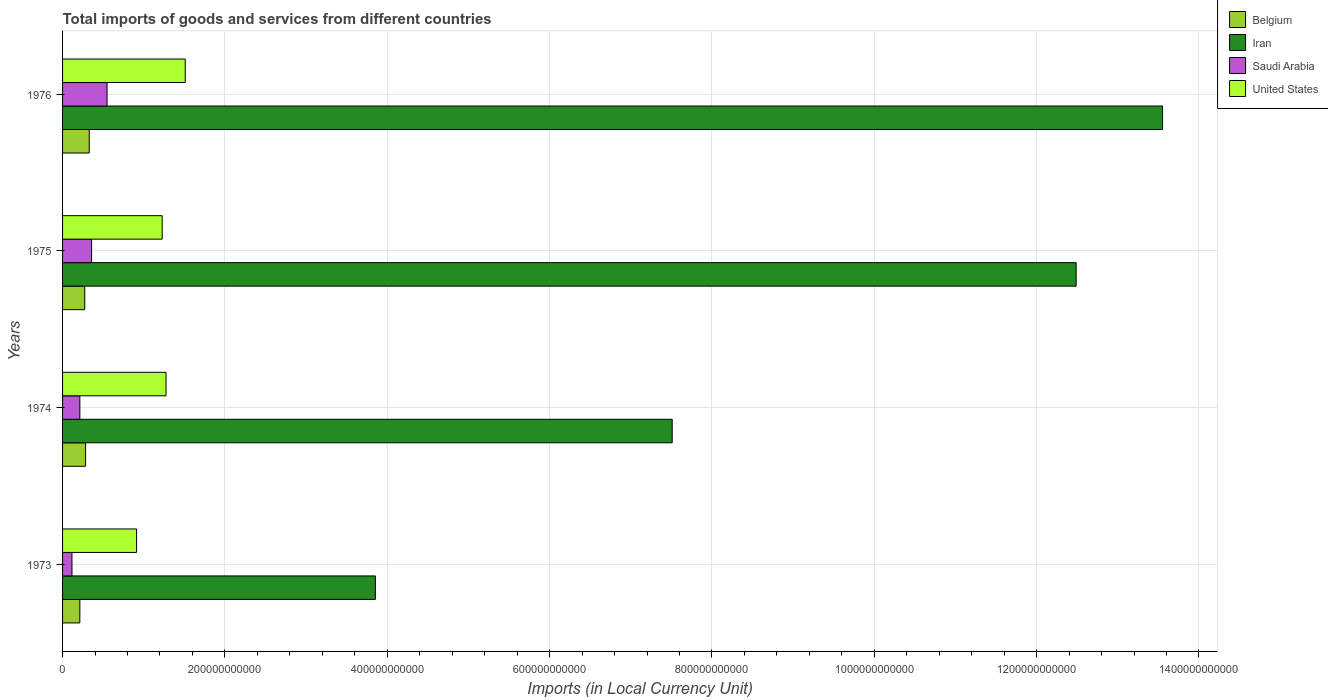How many different coloured bars are there?
Your answer should be very brief. 4. How many bars are there on the 2nd tick from the bottom?
Make the answer very short. 4. What is the label of the 3rd group of bars from the top?
Your response must be concise. 1974. In how many cases, is the number of bars for a given year not equal to the number of legend labels?
Make the answer very short. 0. What is the Amount of goods and services imports in Saudi Arabia in 1974?
Make the answer very short. 2.13e+1. Across all years, what is the maximum Amount of goods and services imports in Iran?
Your answer should be compact. 1.36e+12. Across all years, what is the minimum Amount of goods and services imports in Belgium?
Give a very brief answer. 2.13e+1. In which year was the Amount of goods and services imports in Belgium maximum?
Offer a terse response. 1976. What is the total Amount of goods and services imports in Belgium in the graph?
Your answer should be compact. 1.10e+11. What is the difference between the Amount of goods and services imports in Saudi Arabia in 1974 and that in 1975?
Make the answer very short. -1.45e+1. What is the difference between the Amount of goods and services imports in Iran in 1973 and the Amount of goods and services imports in Belgium in 1976?
Give a very brief answer. 3.52e+11. What is the average Amount of goods and services imports in Belgium per year?
Provide a short and direct response. 2.75e+1. In the year 1975, what is the difference between the Amount of goods and services imports in Saudi Arabia and Amount of goods and services imports in Iran?
Offer a terse response. -1.21e+12. In how many years, is the Amount of goods and services imports in United States greater than 400000000000 LCU?
Offer a terse response. 0. What is the ratio of the Amount of goods and services imports in Saudi Arabia in 1975 to that in 1976?
Offer a very short reply. 0.65. Is the difference between the Amount of goods and services imports in Saudi Arabia in 1974 and 1976 greater than the difference between the Amount of goods and services imports in Iran in 1974 and 1976?
Your answer should be very brief. Yes. What is the difference between the highest and the second highest Amount of goods and services imports in United States?
Your answer should be compact. 2.37e+1. What is the difference between the highest and the lowest Amount of goods and services imports in Iran?
Keep it short and to the point. 9.70e+11. In how many years, is the Amount of goods and services imports in United States greater than the average Amount of goods and services imports in United States taken over all years?
Provide a short and direct response. 2. Is the sum of the Amount of goods and services imports in United States in 1974 and 1975 greater than the maximum Amount of goods and services imports in Belgium across all years?
Offer a terse response. Yes. What does the 1st bar from the top in 1974 represents?
Keep it short and to the point. United States. What does the 2nd bar from the bottom in 1975 represents?
Give a very brief answer. Iran. Are all the bars in the graph horizontal?
Make the answer very short. Yes. What is the difference between two consecutive major ticks on the X-axis?
Your response must be concise. 2.00e+11. Where does the legend appear in the graph?
Your answer should be compact. Top right. How are the legend labels stacked?
Your response must be concise. Vertical. What is the title of the graph?
Provide a succinct answer. Total imports of goods and services from different countries. What is the label or title of the X-axis?
Make the answer very short. Imports (in Local Currency Unit). What is the Imports (in Local Currency Unit) in Belgium in 1973?
Ensure brevity in your answer.  2.13e+1. What is the Imports (in Local Currency Unit) of Iran in 1973?
Make the answer very short. 3.85e+11. What is the Imports (in Local Currency Unit) of Saudi Arabia in 1973?
Offer a very short reply. 1.16e+1. What is the Imports (in Local Currency Unit) of United States in 1973?
Make the answer very short. 9.12e+1. What is the Imports (in Local Currency Unit) of Belgium in 1974?
Provide a short and direct response. 2.84e+1. What is the Imports (in Local Currency Unit) in Iran in 1974?
Offer a terse response. 7.51e+11. What is the Imports (in Local Currency Unit) in Saudi Arabia in 1974?
Offer a terse response. 2.13e+1. What is the Imports (in Local Currency Unit) in United States in 1974?
Give a very brief answer. 1.27e+11. What is the Imports (in Local Currency Unit) of Belgium in 1975?
Your response must be concise. 2.73e+1. What is the Imports (in Local Currency Unit) of Iran in 1975?
Offer a terse response. 1.25e+12. What is the Imports (in Local Currency Unit) in Saudi Arabia in 1975?
Ensure brevity in your answer.  3.58e+1. What is the Imports (in Local Currency Unit) in United States in 1975?
Make the answer very short. 1.23e+11. What is the Imports (in Local Currency Unit) in Belgium in 1976?
Your answer should be compact. 3.29e+1. What is the Imports (in Local Currency Unit) of Iran in 1976?
Your answer should be very brief. 1.36e+12. What is the Imports (in Local Currency Unit) in Saudi Arabia in 1976?
Your answer should be very brief. 5.48e+1. What is the Imports (in Local Currency Unit) in United States in 1976?
Keep it short and to the point. 1.51e+11. Across all years, what is the maximum Imports (in Local Currency Unit) of Belgium?
Offer a terse response. 3.29e+1. Across all years, what is the maximum Imports (in Local Currency Unit) of Iran?
Provide a succinct answer. 1.36e+12. Across all years, what is the maximum Imports (in Local Currency Unit) in Saudi Arabia?
Your answer should be compact. 5.48e+1. Across all years, what is the maximum Imports (in Local Currency Unit) of United States?
Ensure brevity in your answer.  1.51e+11. Across all years, what is the minimum Imports (in Local Currency Unit) of Belgium?
Keep it short and to the point. 2.13e+1. Across all years, what is the minimum Imports (in Local Currency Unit) of Iran?
Offer a terse response. 3.85e+11. Across all years, what is the minimum Imports (in Local Currency Unit) of Saudi Arabia?
Offer a very short reply. 1.16e+1. Across all years, what is the minimum Imports (in Local Currency Unit) of United States?
Keep it short and to the point. 9.12e+1. What is the total Imports (in Local Currency Unit) of Belgium in the graph?
Your answer should be compact. 1.10e+11. What is the total Imports (in Local Currency Unit) of Iran in the graph?
Offer a very short reply. 3.74e+12. What is the total Imports (in Local Currency Unit) of Saudi Arabia in the graph?
Your answer should be very brief. 1.23e+11. What is the total Imports (in Local Currency Unit) in United States in the graph?
Give a very brief answer. 4.92e+11. What is the difference between the Imports (in Local Currency Unit) of Belgium in 1973 and that in 1974?
Offer a terse response. -7.08e+09. What is the difference between the Imports (in Local Currency Unit) of Iran in 1973 and that in 1974?
Your answer should be compact. -3.66e+11. What is the difference between the Imports (in Local Currency Unit) in Saudi Arabia in 1973 and that in 1974?
Offer a very short reply. -9.70e+09. What is the difference between the Imports (in Local Currency Unit) in United States in 1973 and that in 1974?
Give a very brief answer. -3.63e+1. What is the difference between the Imports (in Local Currency Unit) in Belgium in 1973 and that in 1975?
Your answer should be compact. -6.04e+09. What is the difference between the Imports (in Local Currency Unit) of Iran in 1973 and that in 1975?
Provide a succinct answer. -8.63e+11. What is the difference between the Imports (in Local Currency Unit) of Saudi Arabia in 1973 and that in 1975?
Ensure brevity in your answer.  -2.42e+1. What is the difference between the Imports (in Local Currency Unit) in United States in 1973 and that in 1975?
Keep it short and to the point. -3.16e+1. What is the difference between the Imports (in Local Currency Unit) in Belgium in 1973 and that in 1976?
Give a very brief answer. -1.16e+1. What is the difference between the Imports (in Local Currency Unit) of Iran in 1973 and that in 1976?
Provide a short and direct response. -9.70e+11. What is the difference between the Imports (in Local Currency Unit) of Saudi Arabia in 1973 and that in 1976?
Your response must be concise. -4.32e+1. What is the difference between the Imports (in Local Currency Unit) in United States in 1973 and that in 1976?
Offer a terse response. -6.00e+1. What is the difference between the Imports (in Local Currency Unit) in Belgium in 1974 and that in 1975?
Your answer should be compact. 1.03e+09. What is the difference between the Imports (in Local Currency Unit) of Iran in 1974 and that in 1975?
Your answer should be very brief. -4.98e+11. What is the difference between the Imports (in Local Currency Unit) of Saudi Arabia in 1974 and that in 1975?
Keep it short and to the point. -1.45e+1. What is the difference between the Imports (in Local Currency Unit) of United States in 1974 and that in 1975?
Ensure brevity in your answer.  4.74e+09. What is the difference between the Imports (in Local Currency Unit) of Belgium in 1974 and that in 1976?
Offer a very short reply. -4.51e+09. What is the difference between the Imports (in Local Currency Unit) of Iran in 1974 and that in 1976?
Ensure brevity in your answer.  -6.04e+11. What is the difference between the Imports (in Local Currency Unit) in Saudi Arabia in 1974 and that in 1976?
Offer a very short reply. -3.35e+1. What is the difference between the Imports (in Local Currency Unit) in United States in 1974 and that in 1976?
Offer a very short reply. -2.37e+1. What is the difference between the Imports (in Local Currency Unit) in Belgium in 1975 and that in 1976?
Make the answer very short. -5.54e+09. What is the difference between the Imports (in Local Currency Unit) in Iran in 1975 and that in 1976?
Ensure brevity in your answer.  -1.06e+11. What is the difference between the Imports (in Local Currency Unit) of Saudi Arabia in 1975 and that in 1976?
Offer a terse response. -1.90e+1. What is the difference between the Imports (in Local Currency Unit) of United States in 1975 and that in 1976?
Your answer should be very brief. -2.84e+1. What is the difference between the Imports (in Local Currency Unit) of Belgium in 1973 and the Imports (in Local Currency Unit) of Iran in 1974?
Make the answer very short. -7.30e+11. What is the difference between the Imports (in Local Currency Unit) in Belgium in 1973 and the Imports (in Local Currency Unit) in Saudi Arabia in 1974?
Provide a short and direct response. 1.00e+07. What is the difference between the Imports (in Local Currency Unit) of Belgium in 1973 and the Imports (in Local Currency Unit) of United States in 1974?
Your answer should be compact. -1.06e+11. What is the difference between the Imports (in Local Currency Unit) of Iran in 1973 and the Imports (in Local Currency Unit) of Saudi Arabia in 1974?
Provide a succinct answer. 3.64e+11. What is the difference between the Imports (in Local Currency Unit) of Iran in 1973 and the Imports (in Local Currency Unit) of United States in 1974?
Ensure brevity in your answer.  2.58e+11. What is the difference between the Imports (in Local Currency Unit) of Saudi Arabia in 1973 and the Imports (in Local Currency Unit) of United States in 1974?
Offer a very short reply. -1.16e+11. What is the difference between the Imports (in Local Currency Unit) of Belgium in 1973 and the Imports (in Local Currency Unit) of Iran in 1975?
Provide a short and direct response. -1.23e+12. What is the difference between the Imports (in Local Currency Unit) in Belgium in 1973 and the Imports (in Local Currency Unit) in Saudi Arabia in 1975?
Your answer should be very brief. -1.45e+1. What is the difference between the Imports (in Local Currency Unit) of Belgium in 1973 and the Imports (in Local Currency Unit) of United States in 1975?
Offer a very short reply. -1.01e+11. What is the difference between the Imports (in Local Currency Unit) in Iran in 1973 and the Imports (in Local Currency Unit) in Saudi Arabia in 1975?
Make the answer very short. 3.50e+11. What is the difference between the Imports (in Local Currency Unit) in Iran in 1973 and the Imports (in Local Currency Unit) in United States in 1975?
Provide a succinct answer. 2.63e+11. What is the difference between the Imports (in Local Currency Unit) in Saudi Arabia in 1973 and the Imports (in Local Currency Unit) in United States in 1975?
Offer a terse response. -1.11e+11. What is the difference between the Imports (in Local Currency Unit) in Belgium in 1973 and the Imports (in Local Currency Unit) in Iran in 1976?
Make the answer very short. -1.33e+12. What is the difference between the Imports (in Local Currency Unit) in Belgium in 1973 and the Imports (in Local Currency Unit) in Saudi Arabia in 1976?
Your response must be concise. -3.35e+1. What is the difference between the Imports (in Local Currency Unit) in Belgium in 1973 and the Imports (in Local Currency Unit) in United States in 1976?
Make the answer very short. -1.30e+11. What is the difference between the Imports (in Local Currency Unit) in Iran in 1973 and the Imports (in Local Currency Unit) in Saudi Arabia in 1976?
Your response must be concise. 3.31e+11. What is the difference between the Imports (in Local Currency Unit) in Iran in 1973 and the Imports (in Local Currency Unit) in United States in 1976?
Ensure brevity in your answer.  2.34e+11. What is the difference between the Imports (in Local Currency Unit) of Saudi Arabia in 1973 and the Imports (in Local Currency Unit) of United States in 1976?
Your response must be concise. -1.40e+11. What is the difference between the Imports (in Local Currency Unit) in Belgium in 1974 and the Imports (in Local Currency Unit) in Iran in 1975?
Offer a very short reply. -1.22e+12. What is the difference between the Imports (in Local Currency Unit) of Belgium in 1974 and the Imports (in Local Currency Unit) of Saudi Arabia in 1975?
Ensure brevity in your answer.  -7.39e+09. What is the difference between the Imports (in Local Currency Unit) in Belgium in 1974 and the Imports (in Local Currency Unit) in United States in 1975?
Your answer should be very brief. -9.44e+1. What is the difference between the Imports (in Local Currency Unit) in Iran in 1974 and the Imports (in Local Currency Unit) in Saudi Arabia in 1975?
Provide a short and direct response. 7.15e+11. What is the difference between the Imports (in Local Currency Unit) in Iran in 1974 and the Imports (in Local Currency Unit) in United States in 1975?
Make the answer very short. 6.28e+11. What is the difference between the Imports (in Local Currency Unit) of Saudi Arabia in 1974 and the Imports (in Local Currency Unit) of United States in 1975?
Ensure brevity in your answer.  -1.01e+11. What is the difference between the Imports (in Local Currency Unit) in Belgium in 1974 and the Imports (in Local Currency Unit) in Iran in 1976?
Make the answer very short. -1.33e+12. What is the difference between the Imports (in Local Currency Unit) in Belgium in 1974 and the Imports (in Local Currency Unit) in Saudi Arabia in 1976?
Give a very brief answer. -2.64e+1. What is the difference between the Imports (in Local Currency Unit) in Belgium in 1974 and the Imports (in Local Currency Unit) in United States in 1976?
Your response must be concise. -1.23e+11. What is the difference between the Imports (in Local Currency Unit) in Iran in 1974 and the Imports (in Local Currency Unit) in Saudi Arabia in 1976?
Offer a very short reply. 6.96e+11. What is the difference between the Imports (in Local Currency Unit) in Iran in 1974 and the Imports (in Local Currency Unit) in United States in 1976?
Offer a very short reply. 6.00e+11. What is the difference between the Imports (in Local Currency Unit) in Saudi Arabia in 1974 and the Imports (in Local Currency Unit) in United States in 1976?
Keep it short and to the point. -1.30e+11. What is the difference between the Imports (in Local Currency Unit) of Belgium in 1975 and the Imports (in Local Currency Unit) of Iran in 1976?
Offer a terse response. -1.33e+12. What is the difference between the Imports (in Local Currency Unit) of Belgium in 1975 and the Imports (in Local Currency Unit) of Saudi Arabia in 1976?
Provide a succinct answer. -2.75e+1. What is the difference between the Imports (in Local Currency Unit) in Belgium in 1975 and the Imports (in Local Currency Unit) in United States in 1976?
Provide a succinct answer. -1.24e+11. What is the difference between the Imports (in Local Currency Unit) of Iran in 1975 and the Imports (in Local Currency Unit) of Saudi Arabia in 1976?
Provide a succinct answer. 1.19e+12. What is the difference between the Imports (in Local Currency Unit) in Iran in 1975 and the Imports (in Local Currency Unit) in United States in 1976?
Give a very brief answer. 1.10e+12. What is the difference between the Imports (in Local Currency Unit) in Saudi Arabia in 1975 and the Imports (in Local Currency Unit) in United States in 1976?
Keep it short and to the point. -1.15e+11. What is the average Imports (in Local Currency Unit) in Belgium per year?
Provide a succinct answer. 2.75e+1. What is the average Imports (in Local Currency Unit) in Iran per year?
Your response must be concise. 9.35e+11. What is the average Imports (in Local Currency Unit) of Saudi Arabia per year?
Offer a terse response. 3.09e+1. What is the average Imports (in Local Currency Unit) in United States per year?
Provide a short and direct response. 1.23e+11. In the year 1973, what is the difference between the Imports (in Local Currency Unit) of Belgium and Imports (in Local Currency Unit) of Iran?
Your answer should be very brief. -3.64e+11. In the year 1973, what is the difference between the Imports (in Local Currency Unit) in Belgium and Imports (in Local Currency Unit) in Saudi Arabia?
Give a very brief answer. 9.71e+09. In the year 1973, what is the difference between the Imports (in Local Currency Unit) of Belgium and Imports (in Local Currency Unit) of United States?
Your answer should be compact. -6.99e+1. In the year 1973, what is the difference between the Imports (in Local Currency Unit) in Iran and Imports (in Local Currency Unit) in Saudi Arabia?
Your answer should be compact. 3.74e+11. In the year 1973, what is the difference between the Imports (in Local Currency Unit) of Iran and Imports (in Local Currency Unit) of United States?
Your response must be concise. 2.94e+11. In the year 1973, what is the difference between the Imports (in Local Currency Unit) in Saudi Arabia and Imports (in Local Currency Unit) in United States?
Give a very brief answer. -7.96e+1. In the year 1974, what is the difference between the Imports (in Local Currency Unit) in Belgium and Imports (in Local Currency Unit) in Iran?
Offer a terse response. -7.23e+11. In the year 1974, what is the difference between the Imports (in Local Currency Unit) in Belgium and Imports (in Local Currency Unit) in Saudi Arabia?
Offer a terse response. 7.09e+09. In the year 1974, what is the difference between the Imports (in Local Currency Unit) of Belgium and Imports (in Local Currency Unit) of United States?
Provide a succinct answer. -9.91e+1. In the year 1974, what is the difference between the Imports (in Local Currency Unit) in Iran and Imports (in Local Currency Unit) in Saudi Arabia?
Offer a very short reply. 7.30e+11. In the year 1974, what is the difference between the Imports (in Local Currency Unit) in Iran and Imports (in Local Currency Unit) in United States?
Provide a short and direct response. 6.24e+11. In the year 1974, what is the difference between the Imports (in Local Currency Unit) of Saudi Arabia and Imports (in Local Currency Unit) of United States?
Make the answer very short. -1.06e+11. In the year 1975, what is the difference between the Imports (in Local Currency Unit) in Belgium and Imports (in Local Currency Unit) in Iran?
Keep it short and to the point. -1.22e+12. In the year 1975, what is the difference between the Imports (in Local Currency Unit) in Belgium and Imports (in Local Currency Unit) in Saudi Arabia?
Keep it short and to the point. -8.42e+09. In the year 1975, what is the difference between the Imports (in Local Currency Unit) of Belgium and Imports (in Local Currency Unit) of United States?
Your answer should be very brief. -9.54e+1. In the year 1975, what is the difference between the Imports (in Local Currency Unit) of Iran and Imports (in Local Currency Unit) of Saudi Arabia?
Your answer should be very brief. 1.21e+12. In the year 1975, what is the difference between the Imports (in Local Currency Unit) in Iran and Imports (in Local Currency Unit) in United States?
Keep it short and to the point. 1.13e+12. In the year 1975, what is the difference between the Imports (in Local Currency Unit) of Saudi Arabia and Imports (in Local Currency Unit) of United States?
Your answer should be compact. -8.70e+1. In the year 1976, what is the difference between the Imports (in Local Currency Unit) in Belgium and Imports (in Local Currency Unit) in Iran?
Your response must be concise. -1.32e+12. In the year 1976, what is the difference between the Imports (in Local Currency Unit) of Belgium and Imports (in Local Currency Unit) of Saudi Arabia?
Provide a succinct answer. -2.19e+1. In the year 1976, what is the difference between the Imports (in Local Currency Unit) in Belgium and Imports (in Local Currency Unit) in United States?
Your response must be concise. -1.18e+11. In the year 1976, what is the difference between the Imports (in Local Currency Unit) of Iran and Imports (in Local Currency Unit) of Saudi Arabia?
Make the answer very short. 1.30e+12. In the year 1976, what is the difference between the Imports (in Local Currency Unit) of Iran and Imports (in Local Currency Unit) of United States?
Provide a succinct answer. 1.20e+12. In the year 1976, what is the difference between the Imports (in Local Currency Unit) of Saudi Arabia and Imports (in Local Currency Unit) of United States?
Make the answer very short. -9.64e+1. What is the ratio of the Imports (in Local Currency Unit) of Belgium in 1973 to that in 1974?
Give a very brief answer. 0.75. What is the ratio of the Imports (in Local Currency Unit) in Iran in 1973 to that in 1974?
Your response must be concise. 0.51. What is the ratio of the Imports (in Local Currency Unit) in Saudi Arabia in 1973 to that in 1974?
Ensure brevity in your answer.  0.54. What is the ratio of the Imports (in Local Currency Unit) of United States in 1973 to that in 1974?
Provide a succinct answer. 0.72. What is the ratio of the Imports (in Local Currency Unit) in Belgium in 1973 to that in 1975?
Provide a succinct answer. 0.78. What is the ratio of the Imports (in Local Currency Unit) of Iran in 1973 to that in 1975?
Your answer should be compact. 0.31. What is the ratio of the Imports (in Local Currency Unit) in Saudi Arabia in 1973 to that in 1975?
Your answer should be compact. 0.32. What is the ratio of the Imports (in Local Currency Unit) of United States in 1973 to that in 1975?
Your answer should be very brief. 0.74. What is the ratio of the Imports (in Local Currency Unit) of Belgium in 1973 to that in 1976?
Make the answer very short. 0.65. What is the ratio of the Imports (in Local Currency Unit) of Iran in 1973 to that in 1976?
Provide a short and direct response. 0.28. What is the ratio of the Imports (in Local Currency Unit) in Saudi Arabia in 1973 to that in 1976?
Offer a terse response. 0.21. What is the ratio of the Imports (in Local Currency Unit) of United States in 1973 to that in 1976?
Your answer should be very brief. 0.6. What is the ratio of the Imports (in Local Currency Unit) of Belgium in 1974 to that in 1975?
Make the answer very short. 1.04. What is the ratio of the Imports (in Local Currency Unit) of Iran in 1974 to that in 1975?
Give a very brief answer. 0.6. What is the ratio of the Imports (in Local Currency Unit) of Saudi Arabia in 1974 to that in 1975?
Provide a short and direct response. 0.6. What is the ratio of the Imports (in Local Currency Unit) of United States in 1974 to that in 1975?
Provide a succinct answer. 1.04. What is the ratio of the Imports (in Local Currency Unit) of Belgium in 1974 to that in 1976?
Give a very brief answer. 0.86. What is the ratio of the Imports (in Local Currency Unit) in Iran in 1974 to that in 1976?
Ensure brevity in your answer.  0.55. What is the ratio of the Imports (in Local Currency Unit) of Saudi Arabia in 1974 to that in 1976?
Provide a succinct answer. 0.39. What is the ratio of the Imports (in Local Currency Unit) of United States in 1974 to that in 1976?
Offer a terse response. 0.84. What is the ratio of the Imports (in Local Currency Unit) in Belgium in 1975 to that in 1976?
Keep it short and to the point. 0.83. What is the ratio of the Imports (in Local Currency Unit) in Iran in 1975 to that in 1976?
Your answer should be very brief. 0.92. What is the ratio of the Imports (in Local Currency Unit) of Saudi Arabia in 1975 to that in 1976?
Give a very brief answer. 0.65. What is the ratio of the Imports (in Local Currency Unit) of United States in 1975 to that in 1976?
Ensure brevity in your answer.  0.81. What is the difference between the highest and the second highest Imports (in Local Currency Unit) in Belgium?
Provide a short and direct response. 4.51e+09. What is the difference between the highest and the second highest Imports (in Local Currency Unit) of Iran?
Provide a short and direct response. 1.06e+11. What is the difference between the highest and the second highest Imports (in Local Currency Unit) of Saudi Arabia?
Provide a short and direct response. 1.90e+1. What is the difference between the highest and the second highest Imports (in Local Currency Unit) in United States?
Your response must be concise. 2.37e+1. What is the difference between the highest and the lowest Imports (in Local Currency Unit) of Belgium?
Your response must be concise. 1.16e+1. What is the difference between the highest and the lowest Imports (in Local Currency Unit) of Iran?
Offer a very short reply. 9.70e+11. What is the difference between the highest and the lowest Imports (in Local Currency Unit) of Saudi Arabia?
Give a very brief answer. 4.32e+1. What is the difference between the highest and the lowest Imports (in Local Currency Unit) of United States?
Provide a short and direct response. 6.00e+1. 